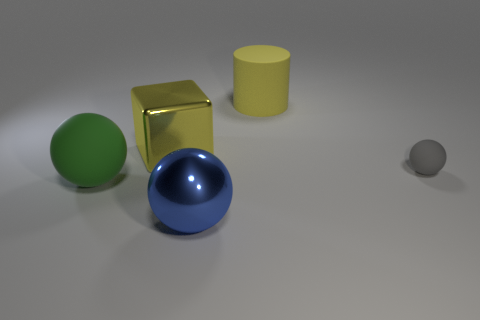What might be the relationship between the objects? The objects don't have an obvious relationship, but their arrangement and varied shapes and colors might suggest an educational or demonstrative purpose, such as a visual aid for teaching about geometry and color theory. 